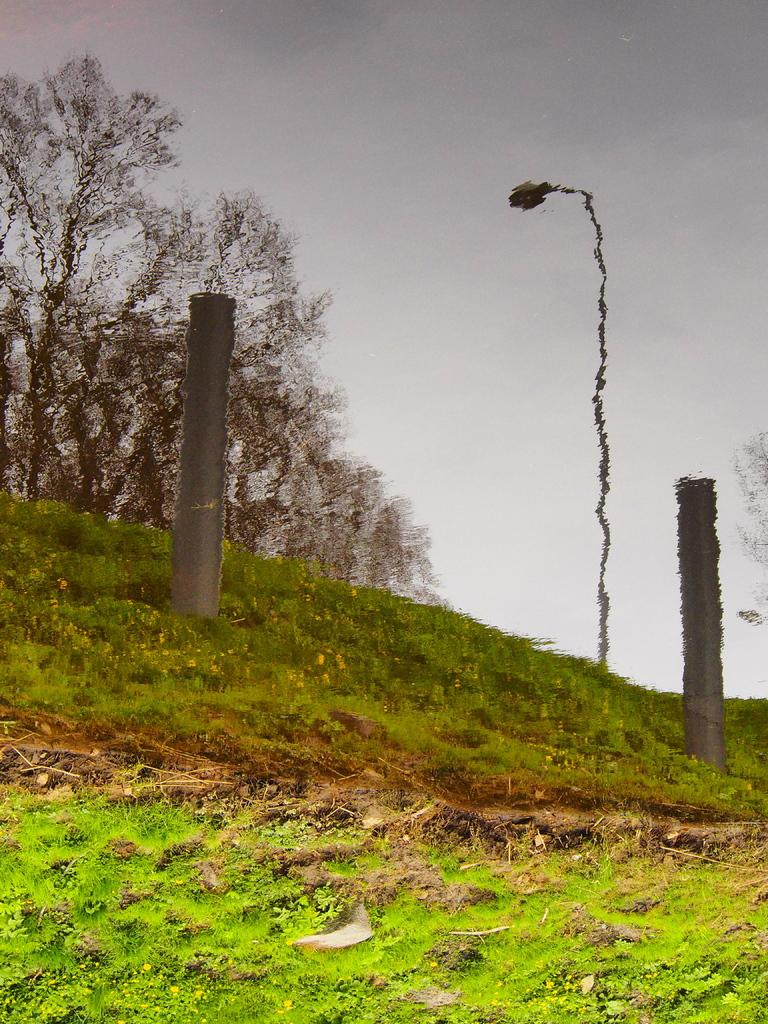What type of vegetation is present in the image? There is grass in the image. What type of man-made structure is visible in the image? There is a street light in the image. What type of barrier is present in the image? There is fencing in the image. What type of natural structure is present in the image? There are trees in the image. What part of the natural environment is visible through the water in the image? The sky is visible through the water in the image. Where is the toad sitting on the throne in the image? There is no toad or throne present in the image. What type of furniture is in the bedroom in the image? There is no bedroom or furniture present in the image. 